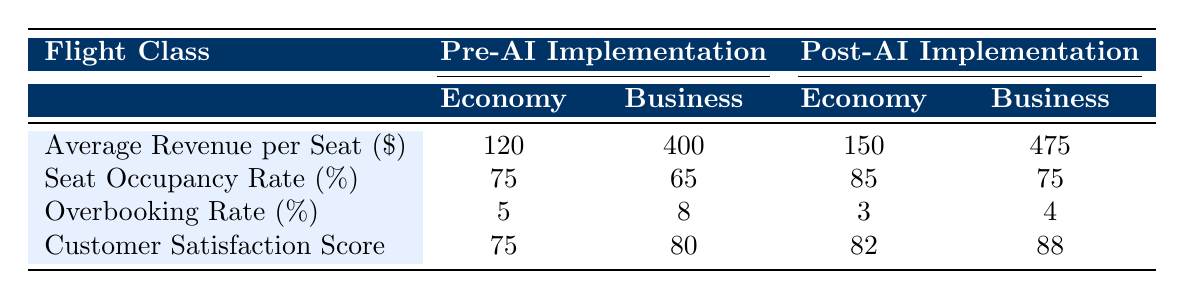What was the average revenue per seat for the Economy class pre-AI implementation? The table shows that for the Economy class, the average revenue per seat before AI implementation was listed under the "Pre-AI Implementation" column. The corresponding value is 120.
Answer: 120 What is the overbooking rate for the Business class post-AI implementation? The table indicates the overbooking rate for the Business class after AI implementation in the "Post-AI Implementation" section. The value is 4.
Answer: 4 Which flight class had a higher increase in average revenue per seat after AI implementation: Economy or Business? To find out which flight class had a higher increase, calculate the difference in average revenue per seat before and after AI implementation for both classes. Economy increased from 120 to 150 (150 - 120 = 30), and Business increased from 400 to 475 (475 - 400 = 75). Business had a higher increase.
Answer: Business Was the customer satisfaction score higher for the Economy class pre-AI or the Business class post-AI implementation? For the Economy class before AI, the customer satisfaction score is 75. For the Business class after AI, the score is 88. Since 88 is greater than 75, the Business class post-AI implementation had a higher score.
Answer: Yes What is the overall change in seat occupancy rate from pre-AI to post-AI implementation for both flight classes combined? The occupancy rates for Economy and Business classes are 75% and 65% for pre-AI, and 85% and 75% for post-AI. Calculate the combined average pre-AI: (75 + 65) / 2 = 70% and for post-AI: (85 + 75) / 2 = 80%. The overall change is 80% - 70% = 10%.
Answer: 10% 